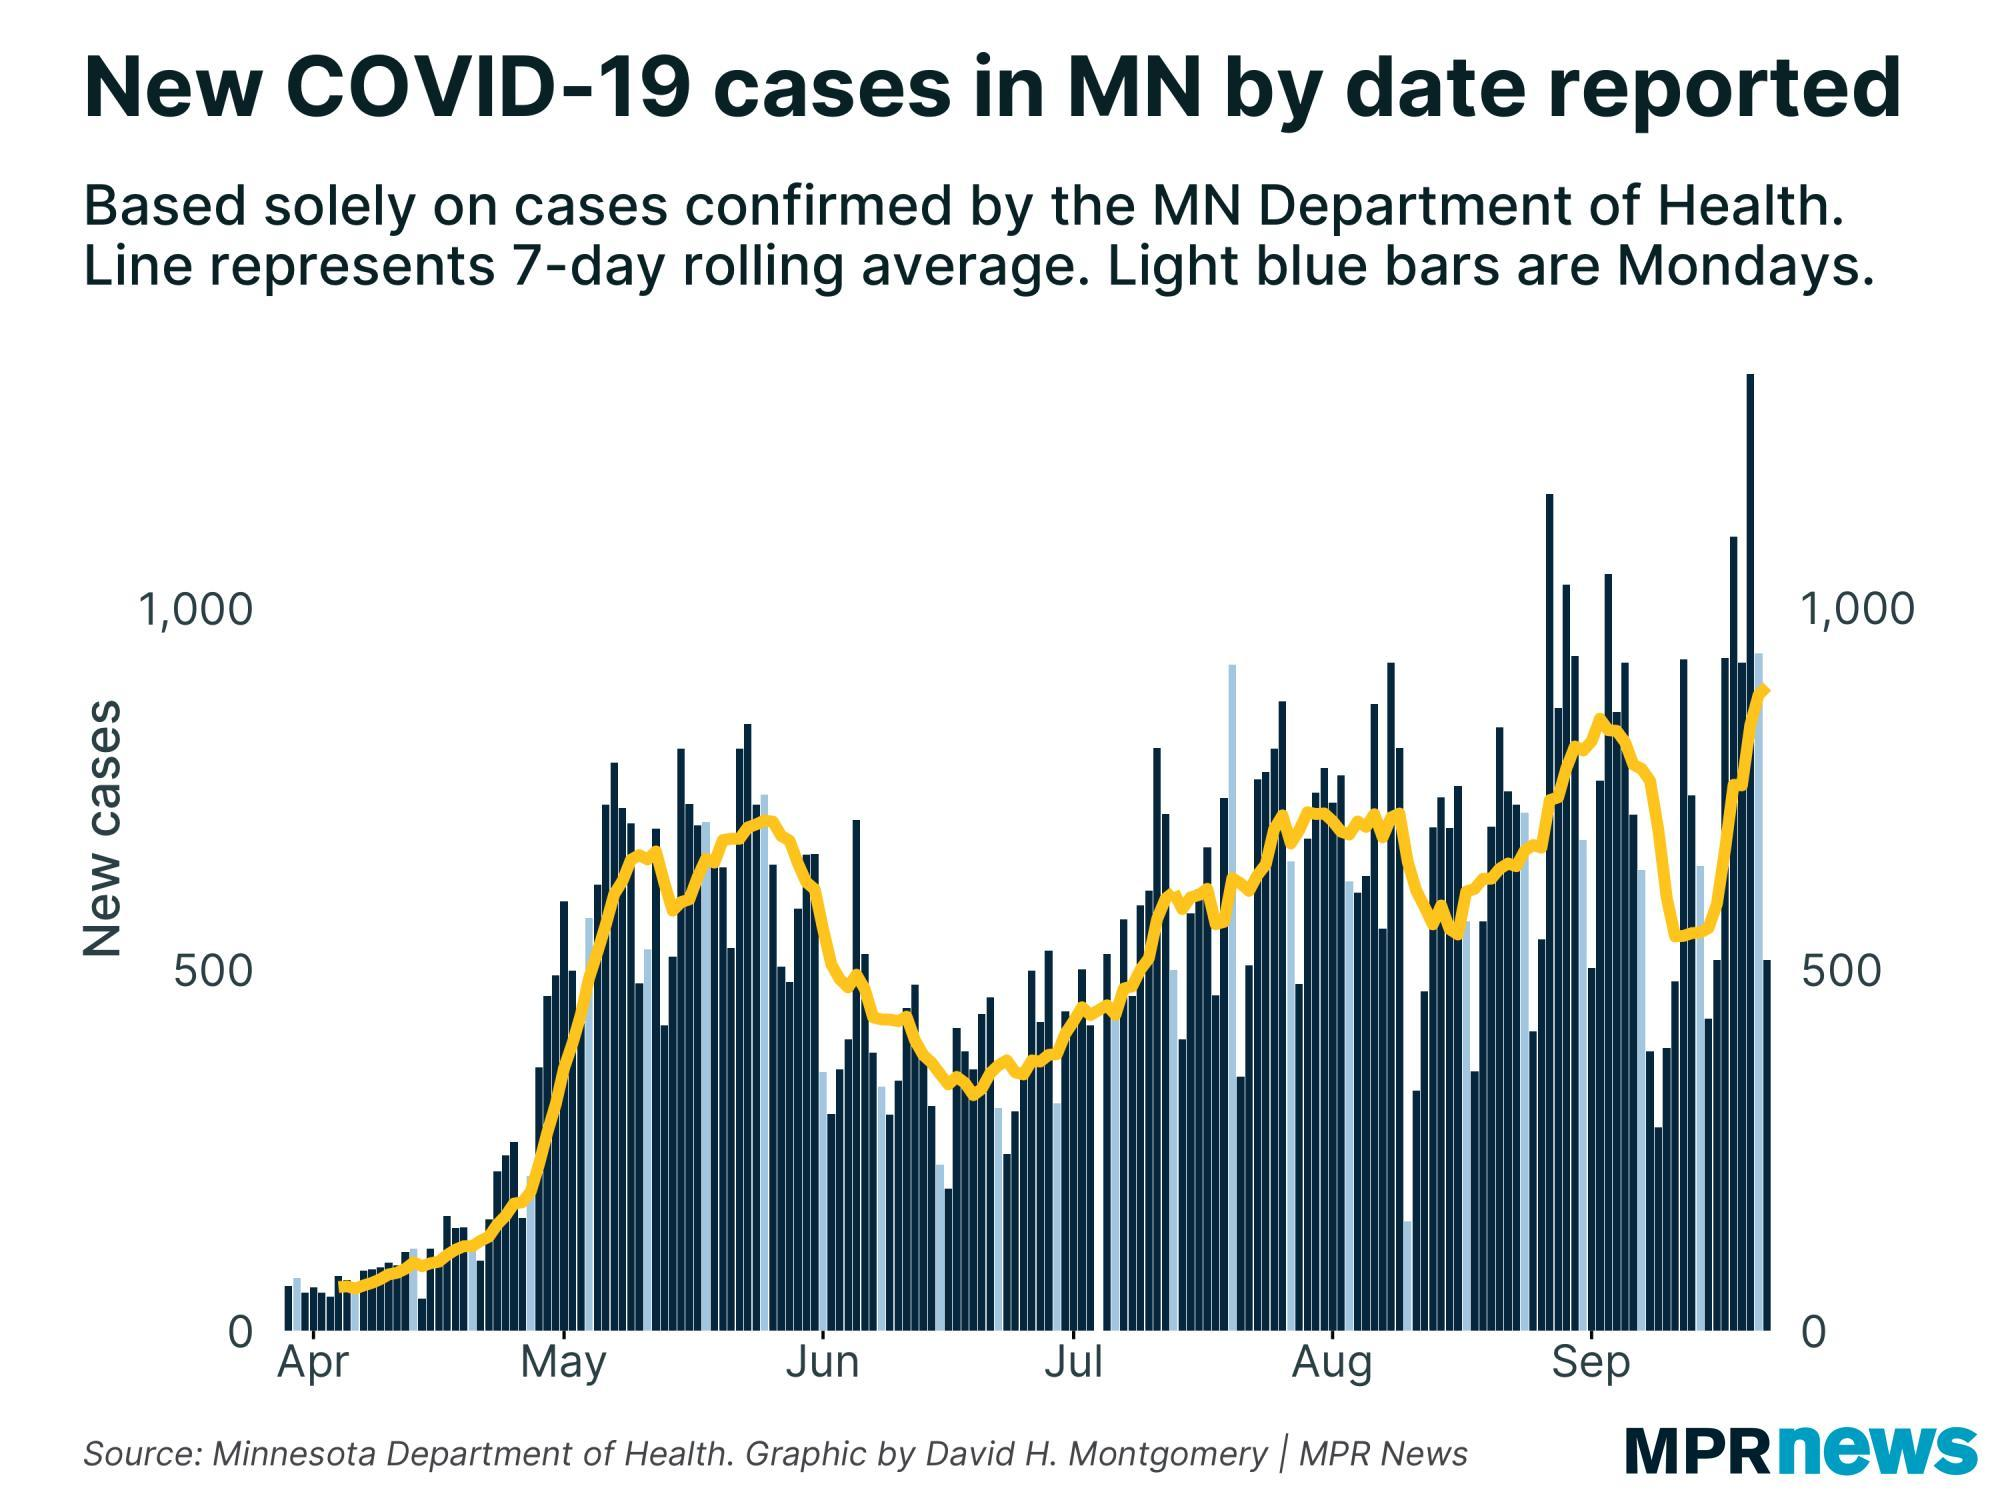how many Mondays between May and June
Answer the question with a short phrase. 5 what is the colour of the line drawn on the graph,yellow or red yellow On which date in April is the first average count taken 7 